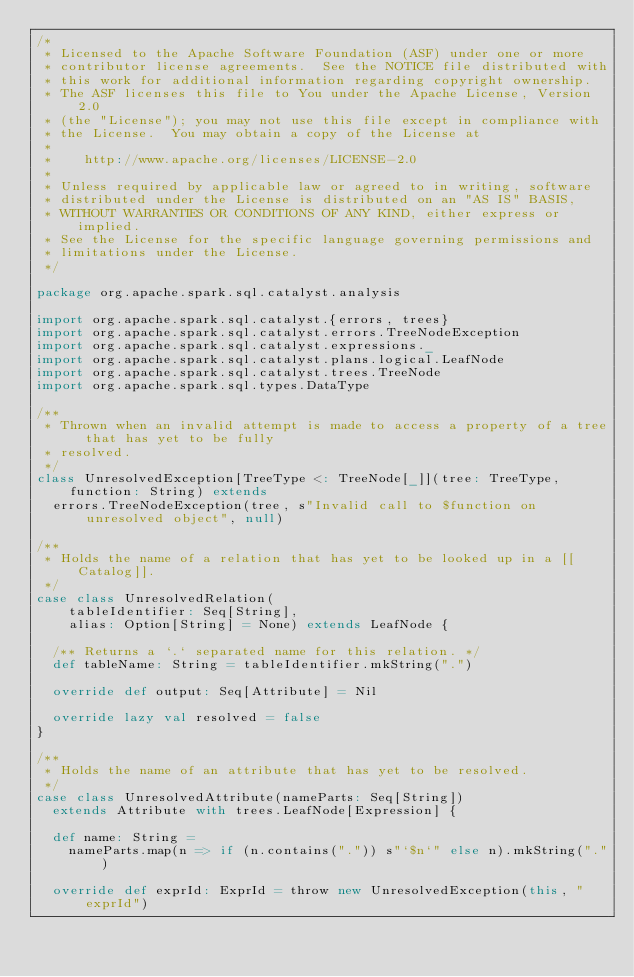<code> <loc_0><loc_0><loc_500><loc_500><_Scala_>/*
 * Licensed to the Apache Software Foundation (ASF) under one or more
 * contributor license agreements.  See the NOTICE file distributed with
 * this work for additional information regarding copyright ownership.
 * The ASF licenses this file to You under the Apache License, Version 2.0
 * (the "License"); you may not use this file except in compliance with
 * the License.  You may obtain a copy of the License at
 *
 *    http://www.apache.org/licenses/LICENSE-2.0
 *
 * Unless required by applicable law or agreed to in writing, software
 * distributed under the License is distributed on an "AS IS" BASIS,
 * WITHOUT WARRANTIES OR CONDITIONS OF ANY KIND, either express or implied.
 * See the License for the specific language governing permissions and
 * limitations under the License.
 */

package org.apache.spark.sql.catalyst.analysis

import org.apache.spark.sql.catalyst.{errors, trees}
import org.apache.spark.sql.catalyst.errors.TreeNodeException
import org.apache.spark.sql.catalyst.expressions._
import org.apache.spark.sql.catalyst.plans.logical.LeafNode
import org.apache.spark.sql.catalyst.trees.TreeNode
import org.apache.spark.sql.types.DataType

/**
 * Thrown when an invalid attempt is made to access a property of a tree that has yet to be fully
 * resolved.
 */
class UnresolvedException[TreeType <: TreeNode[_]](tree: TreeType, function: String) extends
  errors.TreeNodeException(tree, s"Invalid call to $function on unresolved object", null)

/**
 * Holds the name of a relation that has yet to be looked up in a [[Catalog]].
 */
case class UnresolvedRelation(
    tableIdentifier: Seq[String],
    alias: Option[String] = None) extends LeafNode {

  /** Returns a `.` separated name for this relation. */
  def tableName: String = tableIdentifier.mkString(".")

  override def output: Seq[Attribute] = Nil

  override lazy val resolved = false
}

/**
 * Holds the name of an attribute that has yet to be resolved.
 */
case class UnresolvedAttribute(nameParts: Seq[String])
  extends Attribute with trees.LeafNode[Expression] {

  def name: String =
    nameParts.map(n => if (n.contains(".")) s"`$n`" else n).mkString(".")

  override def exprId: ExprId = throw new UnresolvedException(this, "exprId")</code> 